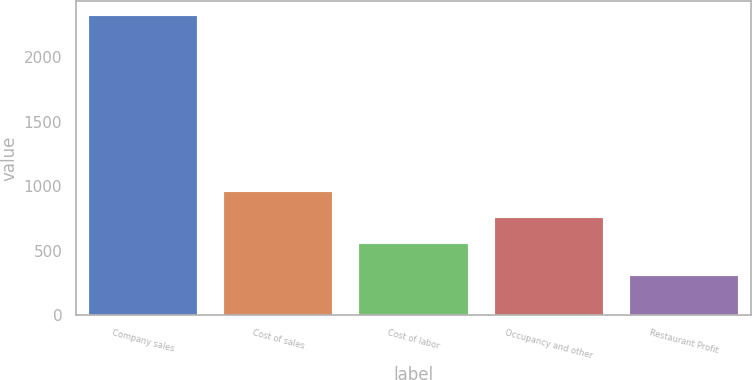<chart> <loc_0><loc_0><loc_500><loc_500><bar_chart><fcel>Company sales<fcel>Cost of sales<fcel>Cost of labor<fcel>Occupancy and other<fcel>Restaurant Profit<nl><fcel>2320<fcel>954.4<fcel>552<fcel>753.2<fcel>308<nl></chart> 